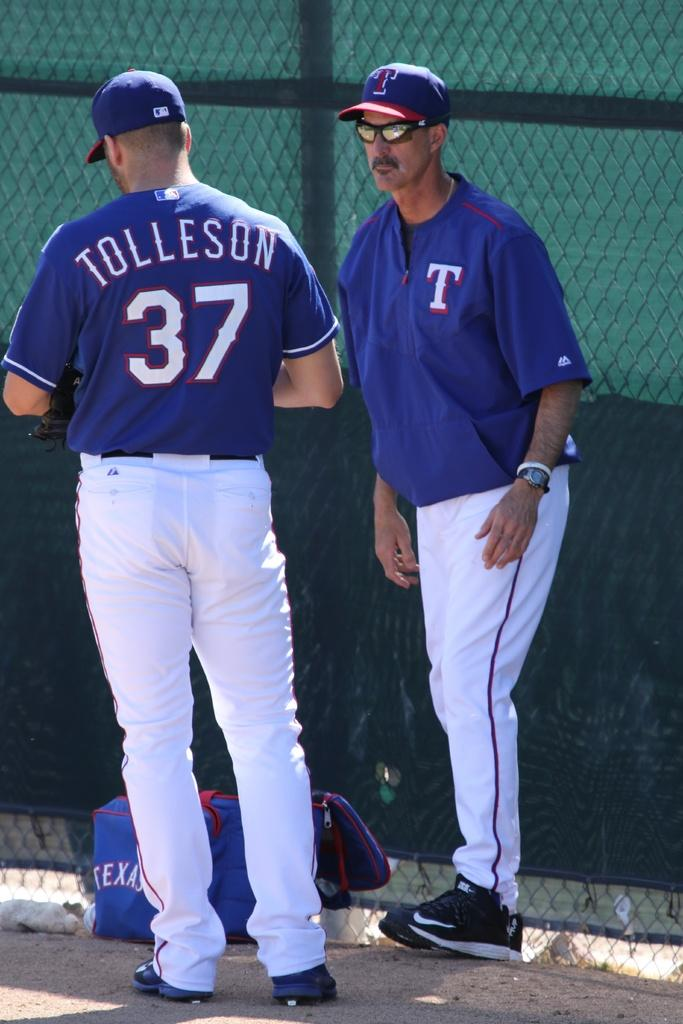<image>
Share a concise interpretation of the image provided. A man wearing a blue and white unifom with Tolleson displayed on his back. 